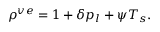<formula> <loc_0><loc_0><loc_500><loc_500>\rho ^ { v e } = 1 + \delta p _ { l } + \psi T _ { s } .</formula> 